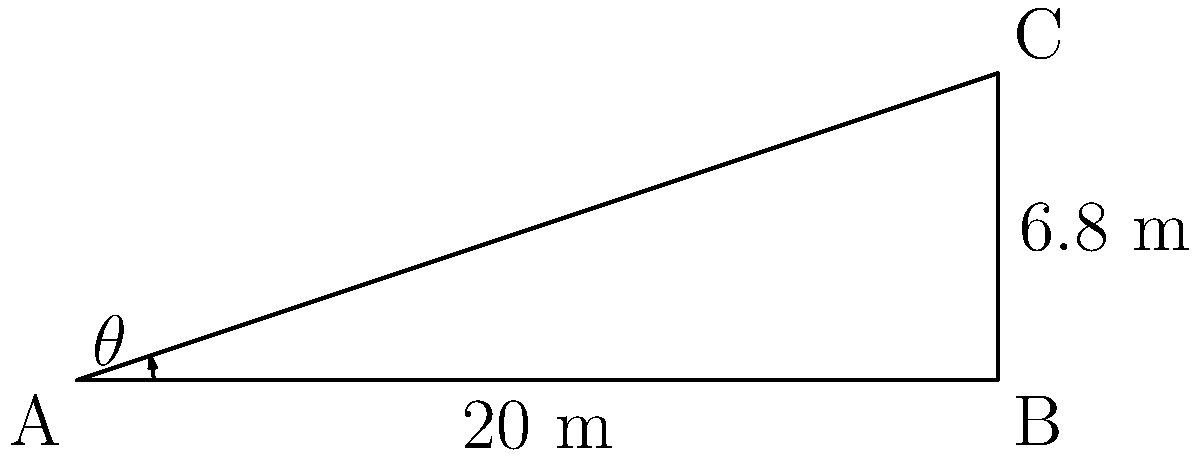At a military base, you need to set up a satellite communication dish. The dish needs to be aimed at a satellite that is directly above point C. If the horizontal distance from the dish (point A) to the building (point B) is 20 meters, and the height of the building is 6.8 meters, what is the angle of elevation ($\theta$) required to aim the dish correctly? Round your answer to the nearest degree. To find the angle of elevation, we need to use trigonometry. Let's approach this step-by-step:

1) We have a right triangle ABC, where:
   - AB is the horizontal distance (20 meters)
   - BC is the height of the building (6.8 meters)
   - AC is the line of sight to the satellite
   - $\theta$ is the angle of elevation we're looking for

2) In a right triangle, we can use the tangent function to find the angle:

   $\tan(\theta) = \frac{\text{opposite}}{\text{adjacent}} = \frac{\text{BC}}{\text{AB}}$

3) Substituting our known values:

   $\tan(\theta) = \frac{6.8}{20}$

4) To find $\theta$, we need to use the inverse tangent (arctan or $\tan^{-1}$):

   $\theta = \tan^{-1}(\frac{6.8}{20})$

5) Using a calculator:

   $\theta = \tan^{-1}(0.34) \approx 18.78^\circ$

6) Rounding to the nearest degree:

   $\theta \approx 19^\circ$
Answer: $19^\circ$ 